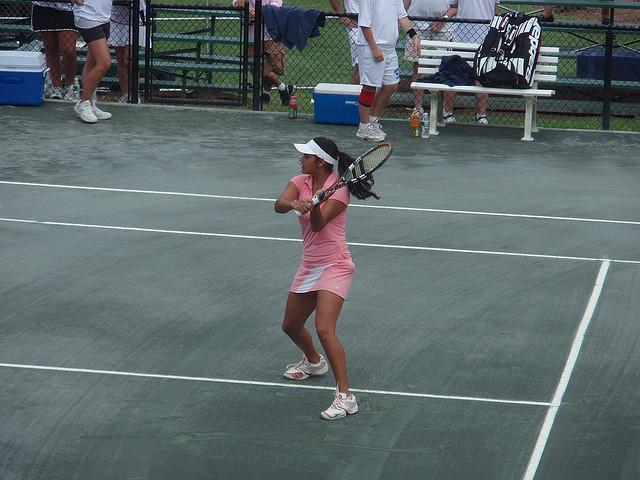What object can keep beverages cold? Please explain your reasoning. cooler. It's in the top left corner. 